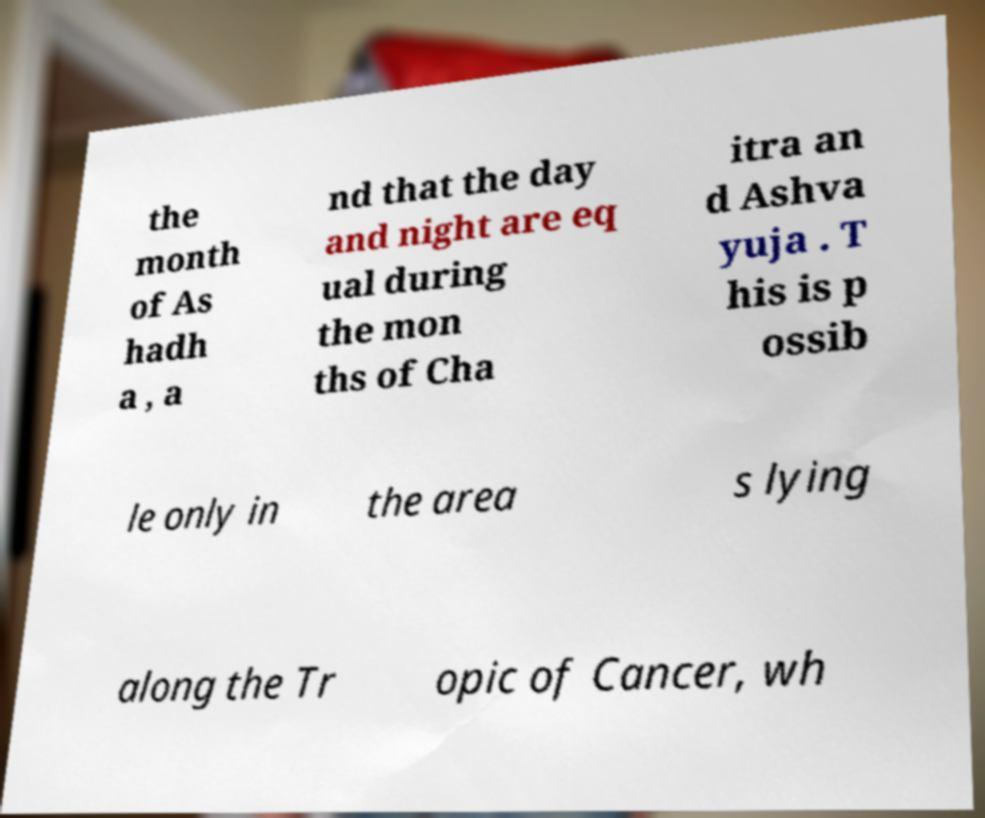For documentation purposes, I need the text within this image transcribed. Could you provide that? the month of As hadh a , a nd that the day and night are eq ual during the mon ths of Cha itra an d Ashva yuja . T his is p ossib le only in the area s lying along the Tr opic of Cancer, wh 